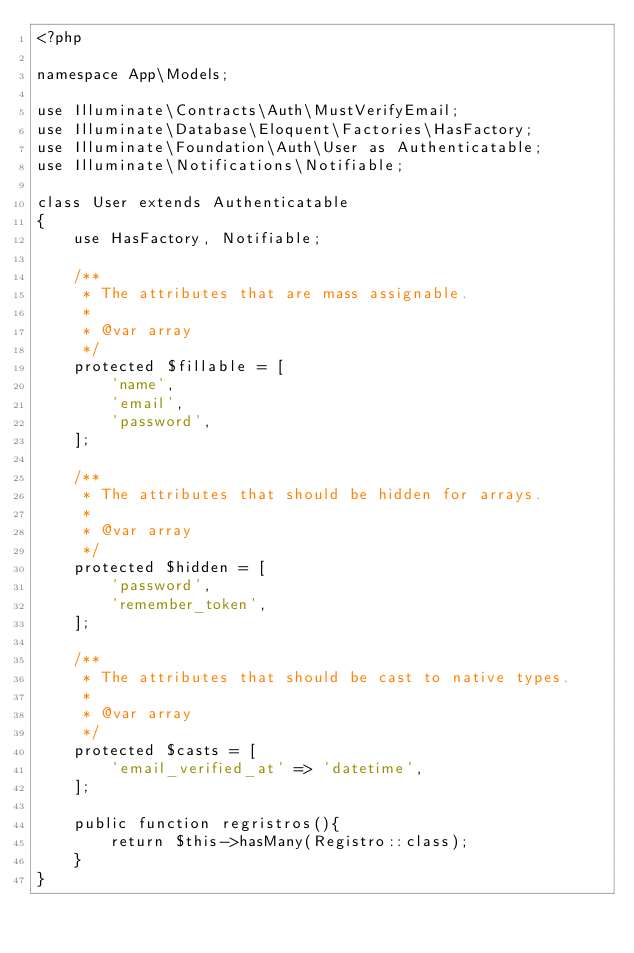<code> <loc_0><loc_0><loc_500><loc_500><_PHP_><?php

namespace App\Models;

use Illuminate\Contracts\Auth\MustVerifyEmail;
use Illuminate\Database\Eloquent\Factories\HasFactory;
use Illuminate\Foundation\Auth\User as Authenticatable;
use Illuminate\Notifications\Notifiable;

class User extends Authenticatable
{
    use HasFactory, Notifiable;

    /**
     * The attributes that are mass assignable.
     *
     * @var array
     */
    protected $fillable = [
        'name',
        'email',
        'password',
    ];

    /**
     * The attributes that should be hidden for arrays.
     *
     * @var array
     */
    protected $hidden = [
        'password',
        'remember_token',
    ];

    /**
     * The attributes that should be cast to native types.
     *
     * @var array
     */
    protected $casts = [
        'email_verified_at' => 'datetime',
    ];

    public function regristros(){
        return $this->hasMany(Registro::class);
    }
}
</code> 